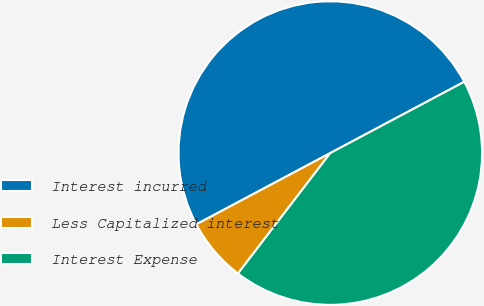<chart> <loc_0><loc_0><loc_500><loc_500><pie_chart><fcel>Interest incurred<fcel>Less Capitalized interest<fcel>Interest Expense<nl><fcel>50.0%<fcel>6.81%<fcel>43.19%<nl></chart> 